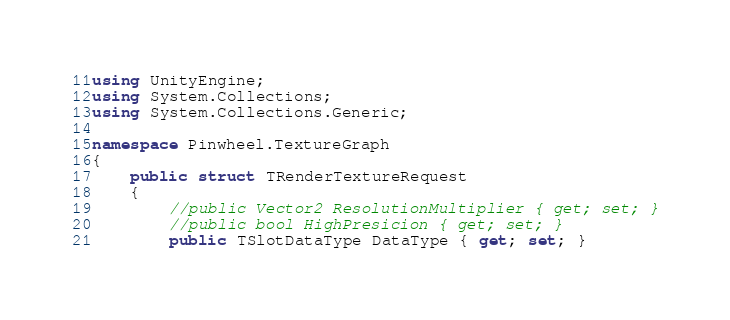<code> <loc_0><loc_0><loc_500><loc_500><_C#_>using UnityEngine;
using System.Collections;
using System.Collections.Generic;

namespace Pinwheel.TextureGraph
{
    public struct TRenderTextureRequest
    {
        //public Vector2 ResolutionMultiplier { get; set; }
        //public bool HighPresicion { get; set; }
        public TSlotDataType DataType { get; set; }</code> 